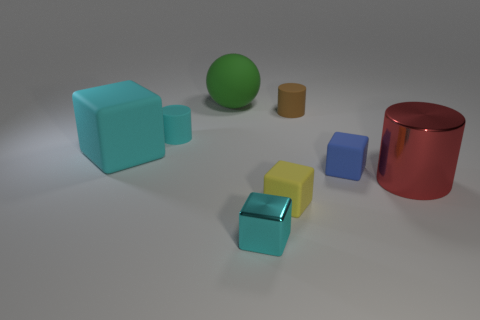Add 1 large shiny cubes. How many objects exist? 9 Subtract 0 gray blocks. How many objects are left? 8 Subtract all balls. How many objects are left? 7 Subtract all big yellow cylinders. Subtract all cyan things. How many objects are left? 5 Add 3 tiny blue things. How many tiny blue things are left? 4 Add 8 big metallic things. How many big metallic things exist? 9 